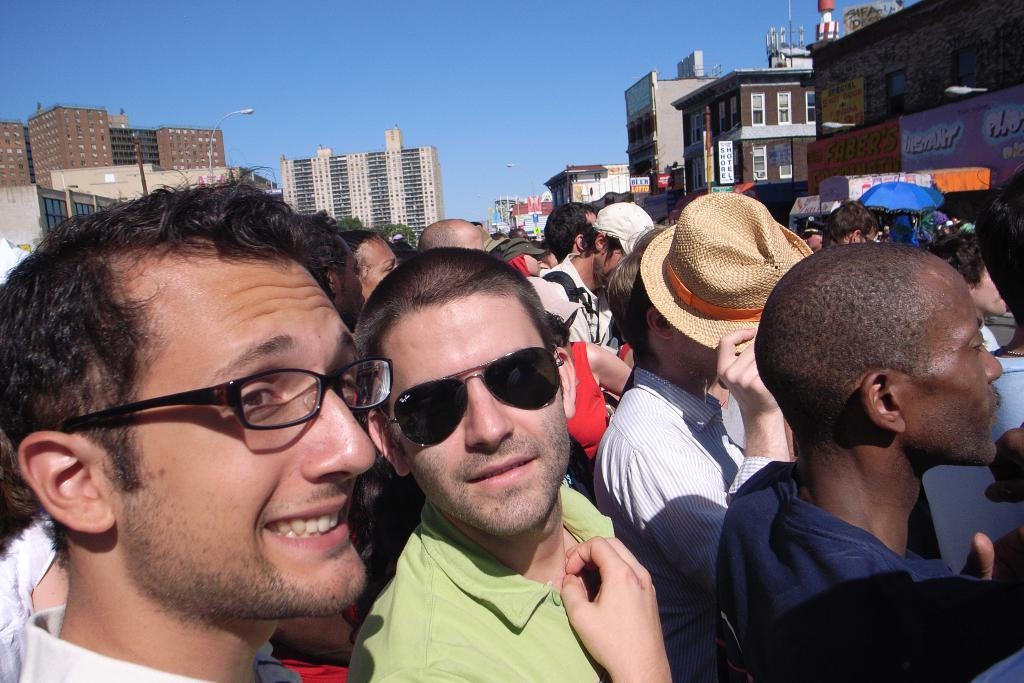What is happening in the image? There are people standing in the image. What can be seen in the background of the image? There are many buildings and some poles in the background of the image. What is visible at the top of the image? The sky is visible at the top of the image. How many sisters are playing with the boats in the image? There are no sisters or boats present in the image. 